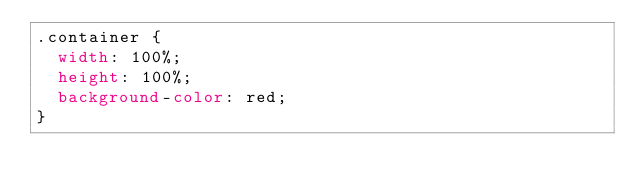Convert code to text. <code><loc_0><loc_0><loc_500><loc_500><_CSS_>.container {
  width: 100%;
  height: 100%;
  background-color: red;
}
</code> 